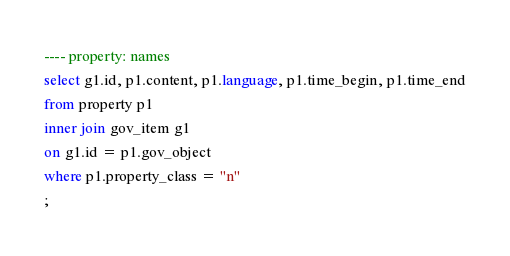<code> <loc_0><loc_0><loc_500><loc_500><_SQL_>---- property: names
select g1.id, p1.content, p1.language, p1.time_begin, p1.time_end
from property p1
inner join gov_item g1
on g1.id = p1.gov_object 
where p1.property_class = "n"
;
</code> 